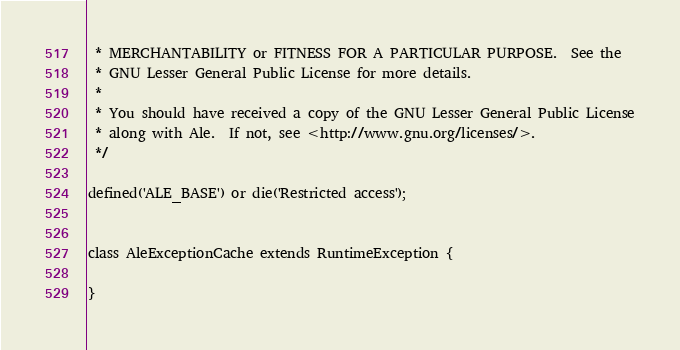<code> <loc_0><loc_0><loc_500><loc_500><_PHP_> * MERCHANTABILITY or FITNESS FOR A PARTICULAR PURPOSE.  See the
 * GNU Lesser General Public License for more details.
 * 
 * You should have received a copy of the GNU Lesser General Public License
 * along with Ale.  If not, see <http://www.gnu.org/licenses/>.
 */

defined('ALE_BASE') or die('Restricted access');


class AleExceptionCache extends RuntimeException {
	
}</code> 